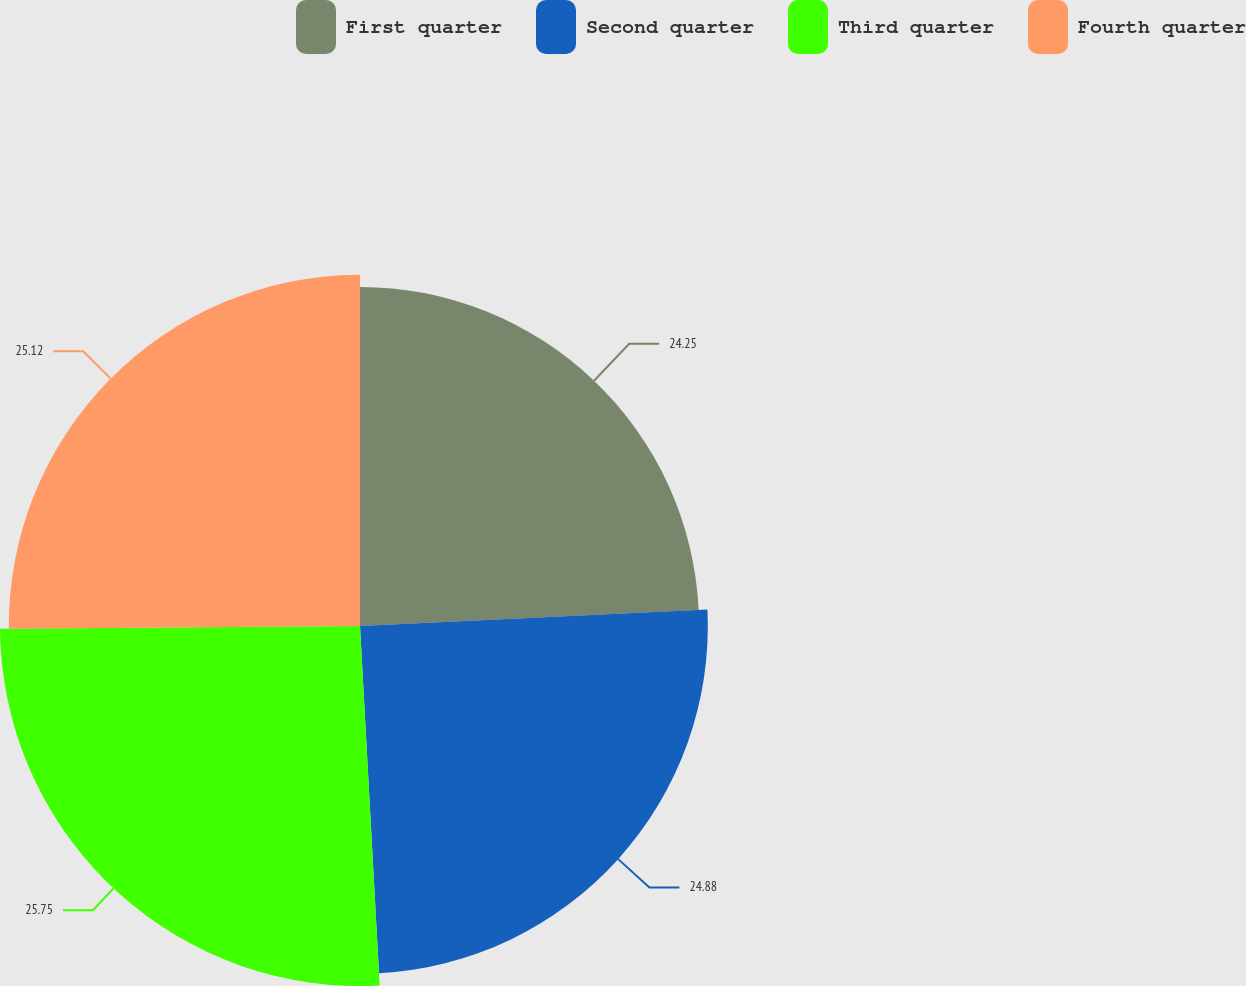<chart> <loc_0><loc_0><loc_500><loc_500><pie_chart><fcel>First quarter<fcel>Second quarter<fcel>Third quarter<fcel>Fourth quarter<nl><fcel>24.25%<fcel>24.88%<fcel>25.75%<fcel>25.12%<nl></chart> 